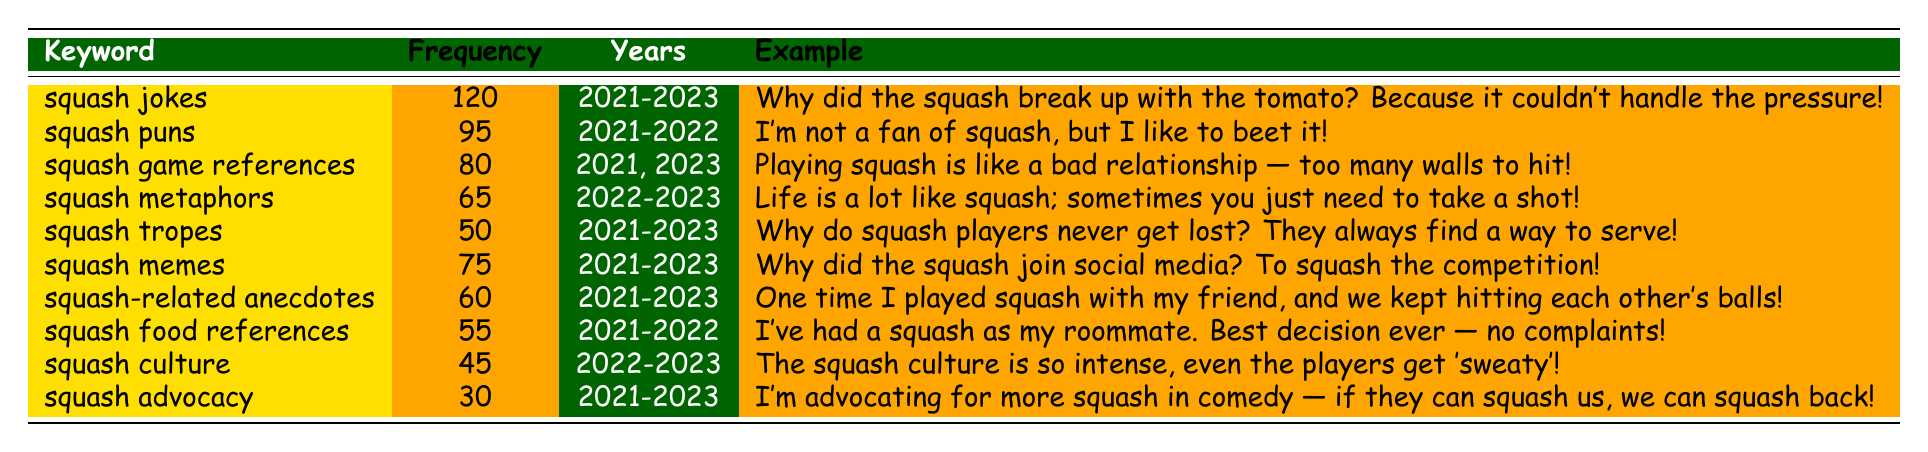What is the frequency of "squash jokes"? The table shows the frequency of "squash jokes," which is given directly as 120.
Answer: 120 How many years did "squash puns" appear in the table? The entry for "squash puns" indicates it appeared in the years 2021 and 2022, which totals to 2 years.
Answer: 2 years Which squash keyword has the lowest frequency? By examining the frequencies in the table, "squash advocacy" has the lowest frequency at 30.
Answer: "squash advocacy" Is "squash culture" included in the years 2021 and 2022? The table indicates "squash culture" was present only in 2022 and 2023, meaning it is not included in 2021.
Answer: No What is the total frequency of keywords that mention "squash" for 2021? The total frequency for 2021 includes "squash jokes" (120), "squash puns" (95), "squash game references" (80), "squash tropes" (50), "squash memes" (75), "squash-related anecdotes" (60), "squash food references" (55), and "squash advocacy" (30). The sum is 120 + 95 + 80 + 50 + 75 + 60 + 55 + 30 = 565.
Answer: 565 How many keywords have a frequency of 60 or higher? Looking at the table, the keywords with a frequency of 60 or higher are "squash jokes" (120), "squash puns" (95), "squash game references" (80), "squash memes" (75), "squash-related anecdotes" (60), and "squash metaphors" (65). This counts to a total of 6 keywords.
Answer: 6 keywords In which year did "squash metaphors" have the highest frequency? "Squash metaphors" appears during 2022 and 2023, having a frequency of 65, and no higher values are noted for those years, thus, they share the same frequency.
Answer: 2022 and 2023 Are there any keywords that appeared in all three years? Analyzing the years listed for each keyword, both "squash jokes," "squash tropes," "squash memes," "squash-related anecdotes," and "squash advocacy" are the keywords present in all three years. Therefore, there are five keywords.
Answer: Yes, five keywords 